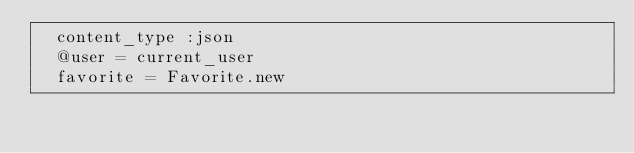Convert code to text. <code><loc_0><loc_0><loc_500><loc_500><_Ruby_>  content_type :json
  @user = current_user
  favorite = Favorite.new</code> 